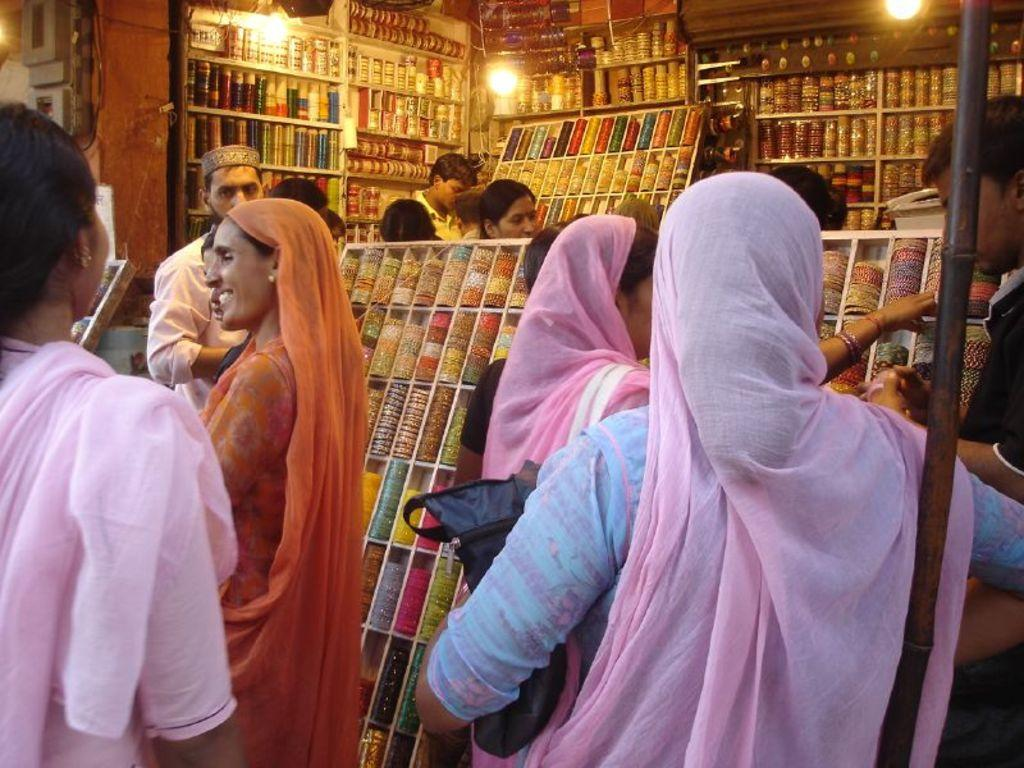What type of store is shown in the image? There is a bangle store in the image. Can you describe the people in the image? There are people standing in the image. What can be seen illuminating the scene in the image? There are lights visible in the image. What is the woman holding in the image? The woman is holding a bag in the image. What accessory is the man wearing in the image? The man is wearing a cap in the image. What type of cheese is being sold in the bangle store in the image? There is no cheese being sold in the bangle store in the image; it is a store that sells bangles. What color is the sheet draped over the mannequin in the image? There is no sheet present in the image; it is a bangle store with people and lights visible. 